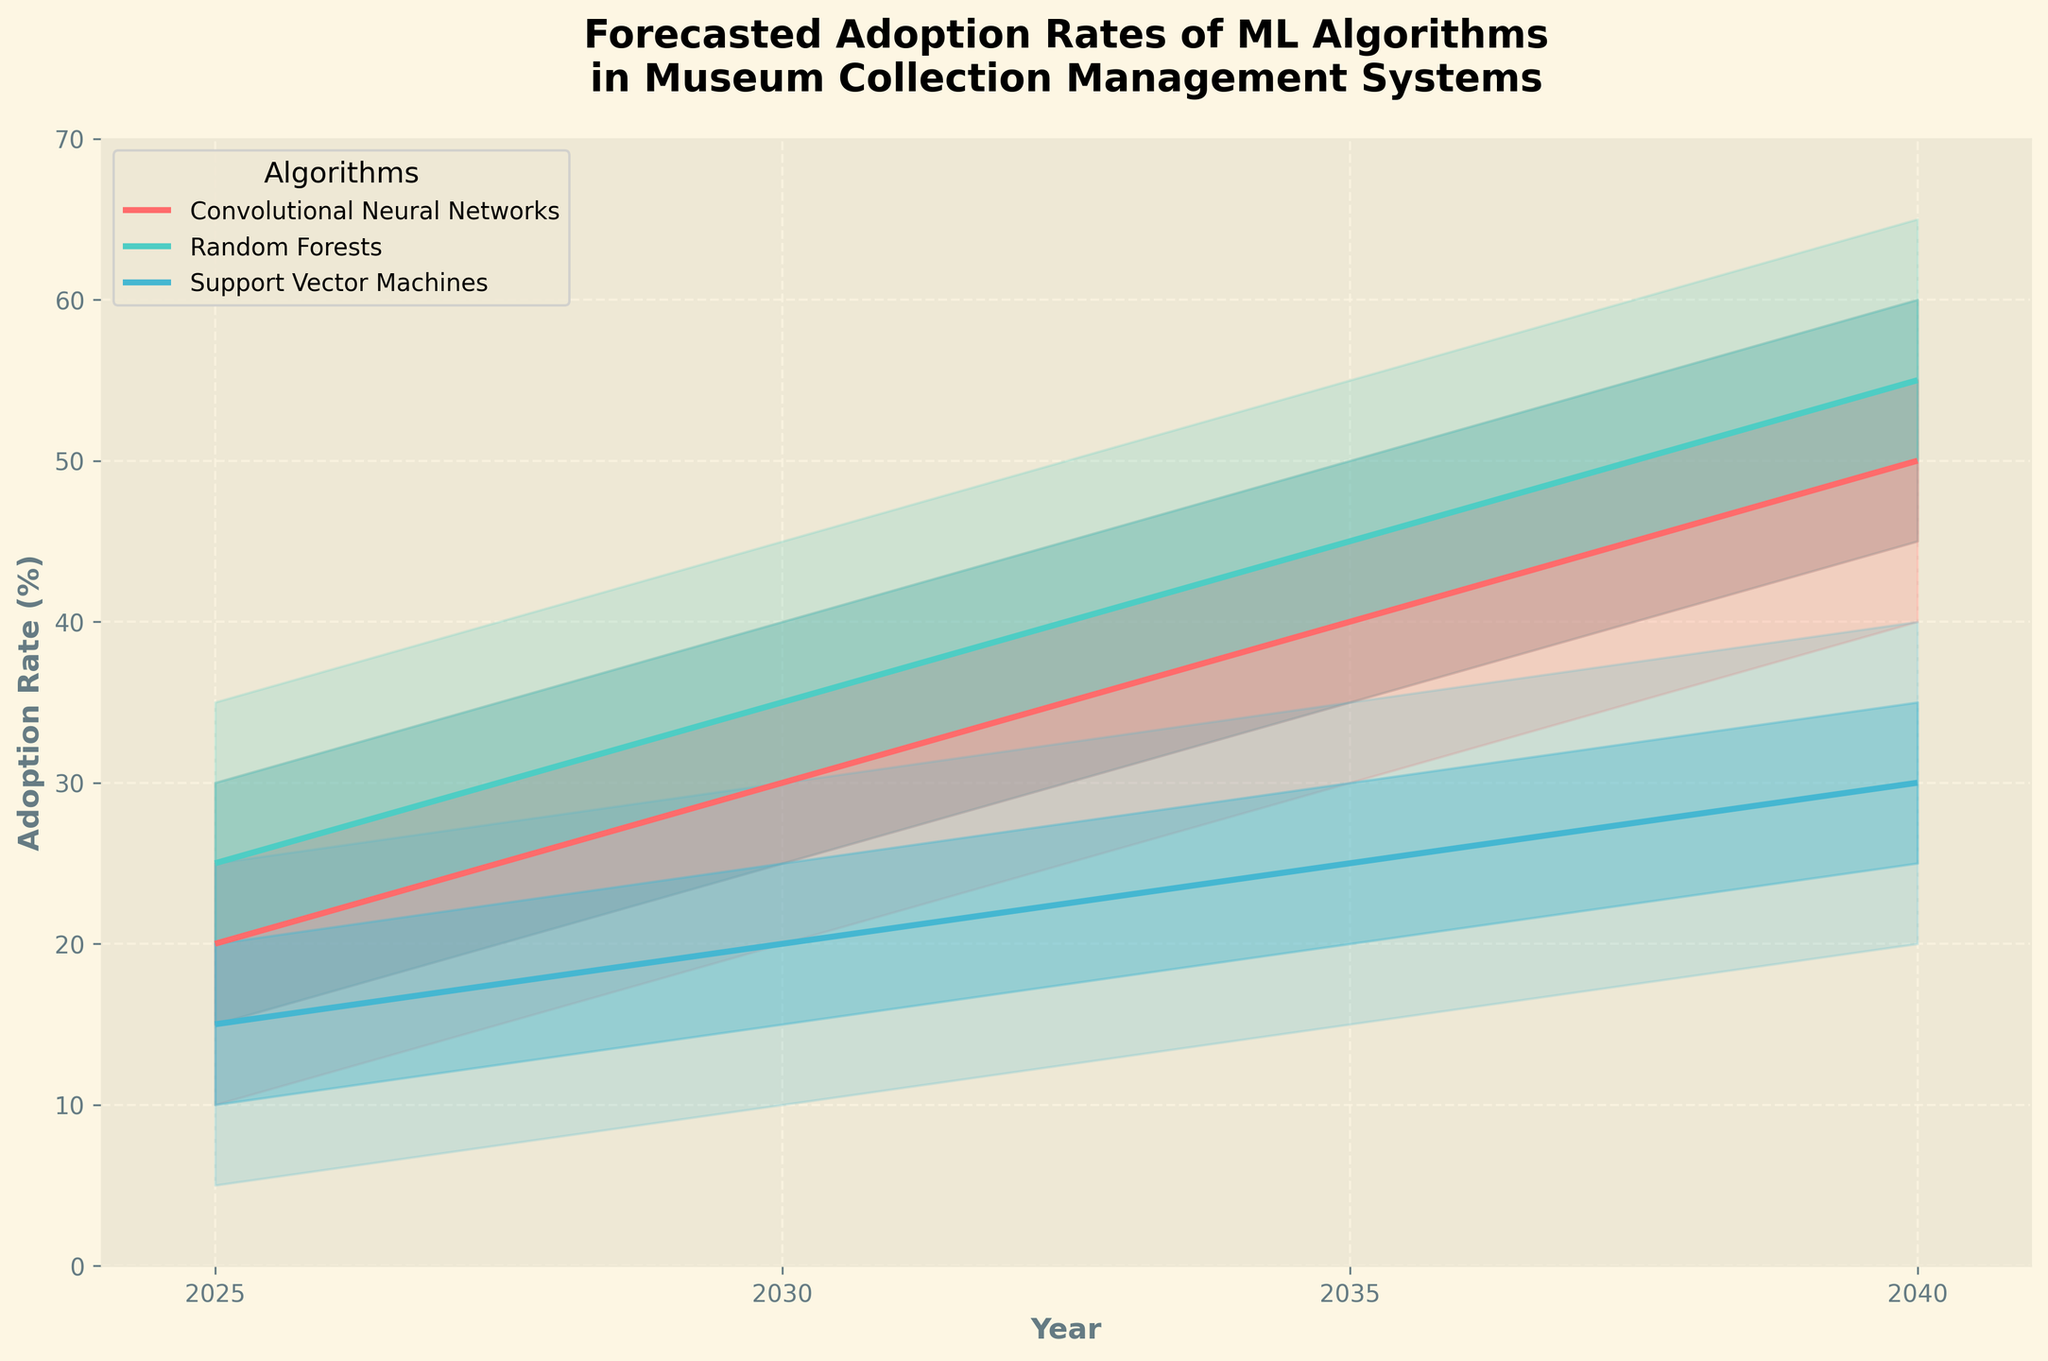What is the range of adoption rates for Convolutional Neural Networks (CNNs) in 2040? In 2040, the adoption rates for CNNs span from 40% to 60%. This is indicated by the lowest value on the "Low" path and the highest value on the "High" path for CNNs at the year 2040.
Answer: 40% to 60% Which algorithm has the highest median forecasted adoption rate in 2035? In 2035, the median adoption rates are: CNNs (40%), Random Forests (45%), and Support Vector Machines (25%). Among these, Random Forests have the highest median forecasted adoption rate.
Answer: Random Forests How does the adoption rate change for Support Vector Machines (SVMs) from 2025 to 2040? The median forecasted adoption rate for SVMs rises from 15% in 2025 to 30% in 2040. The difference is 30% - 15% = 15%, indicating an increase.
Answer: It increases by 15% Compare the rate of increase in median adoption between CNNs and Random Forests from 2025 to 2040. For CNNs, the median adoption rate increases from 20% in 2025 to 50% in 2040, an increase of 30%. For Random Forests, it increases from 25% in 2025 to 55% in 2040, an increase of 30%. Therefore, both algorithms exhibit the same increase in adoption rate over the given period.
Answer: Both increase by 30% What is the adoption range for Random Forests in 2030? In 2030, the adoption rates for Random Forests have a range from 25% (Low) to 45% (High), as indicated by the lowest and highest values for Random Forests at that year.
Answer: 25% to 45% Which algorithm is predicted to have the lowest adoption rate in 2025? The lowest mid-value in 2025 among the algorithms is for Support Vector Machines, which have a median adoption rate of 15%.
Answer: Support Vector Machines How is the variability of CNN adoption rates in 2040 compared to 2025? In 2040, CNNs have an adoption range of 40% to 60% (a span of 20%). In 2025, the range is 10% to 30% (also a span of 20%). Thus, the variability in the adoption rates for CNNs remains the same across 2025 and 2040.
Answer: It remains the same Which algorithm’s adoption rate shows a consistent increase across all years? CNNs, Random Forests, and Support Vector Machines all show a consistent increase in their adoption rates across 2025, 2030, 2035, and 2040 as their median forecasted adoption rates increase in each subsequent period.
Answer: All three algorithms Between 2025 and 2030, which algorithm sees the greatest increase in median forecasted adoption rates? For CNNs, the increase is from 20% to 30% (10%). For Random Forests, from 25% to 35% (10%). For SVMs, from 15% to 20% (5%). Thus, CNNs and Random Forests see the greatest increase in median forecasted adoption rates, each increasing by 10%.
Answer: CNNs and Random Forests 